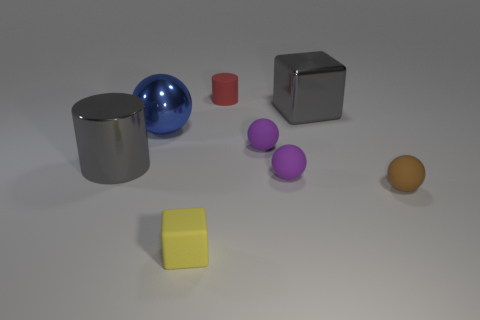What is the texture of the objects, do they seem smooth or rough? Most objects in the image have a smooth texture, visibly seen on the surfaces of the gray cylinder, the blue sphere, the red and silver cubes, and the yellow cube. The two purple spheres also seem smooth, suggesting they are likely made from a similar material. 